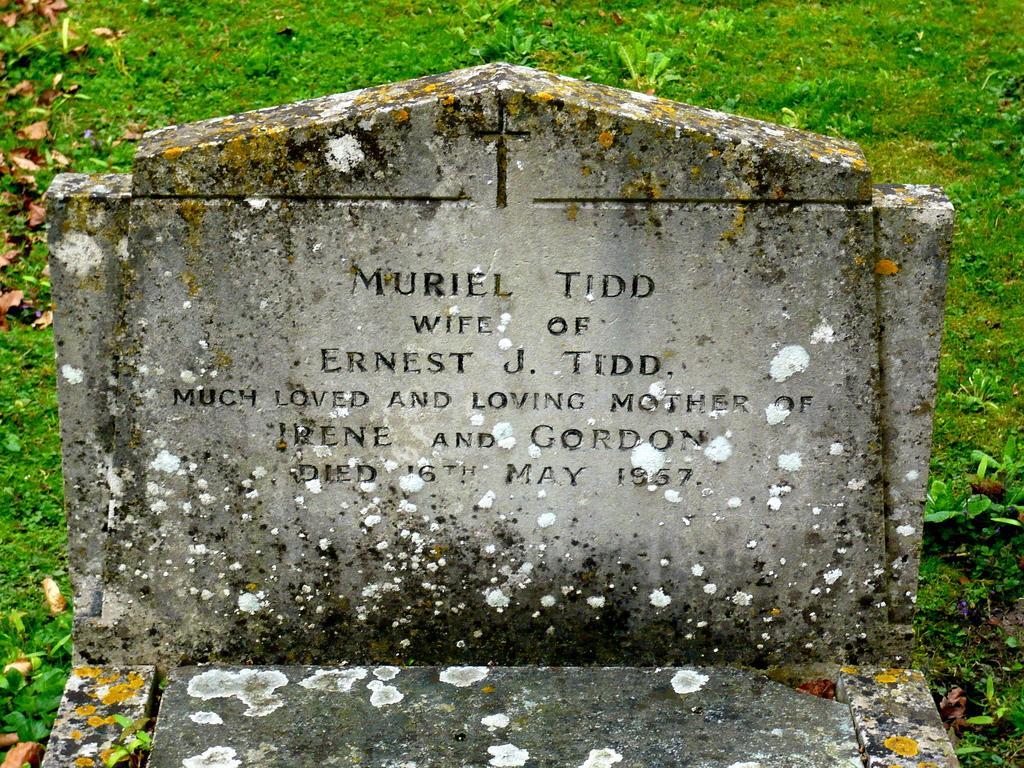Could you give a brief overview of what you see in this image? In the picture there is a grave of a woman and behind the grave there is a green grass. 